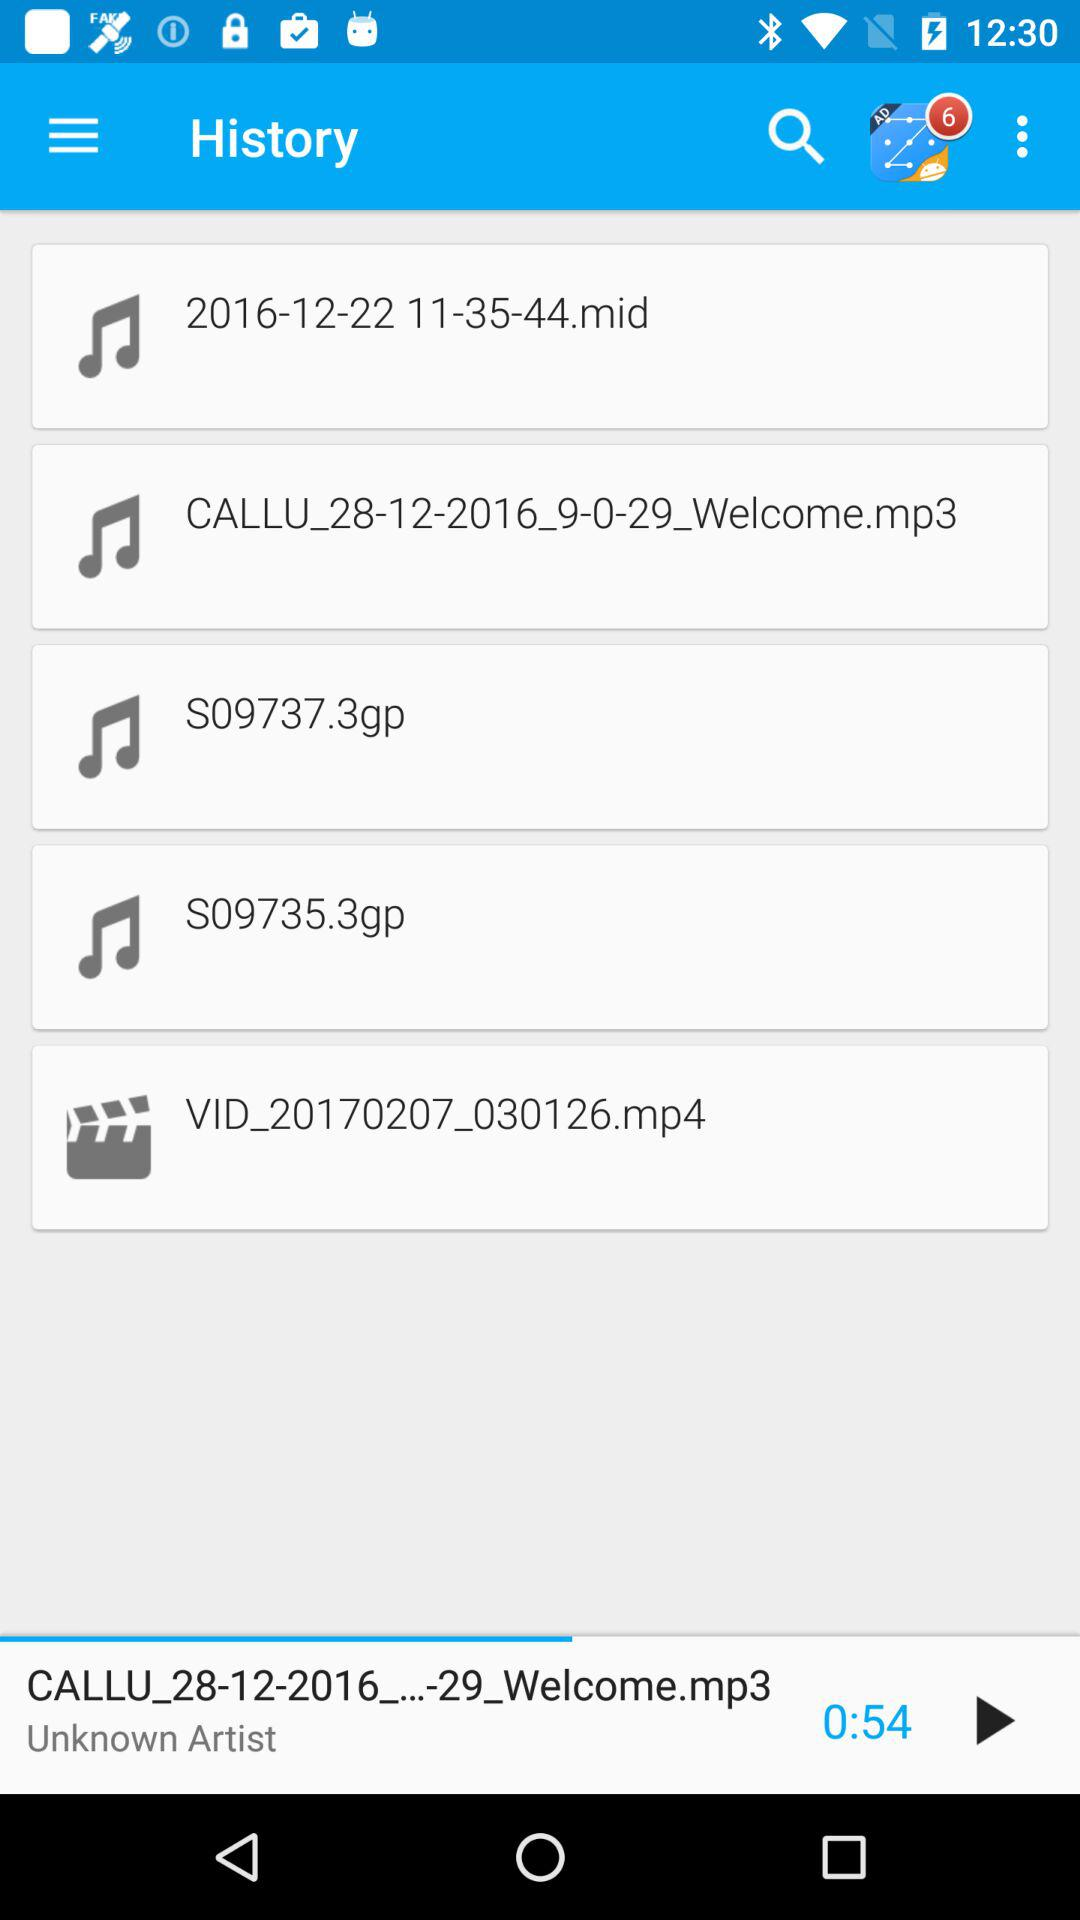Which audio was last played on the screen? The audio "CALLU_28-12-2016_...-29_Welcome.mp3" was last played on the screen. 